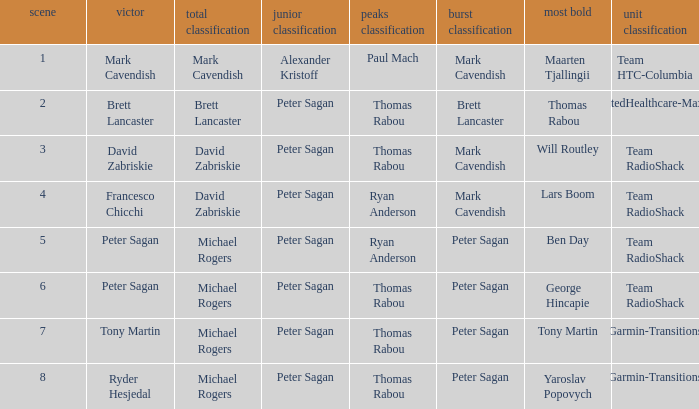When Mark Cavendish wins sprint classification and Maarten Tjallingii wins most courageous, who wins youth classification? Alexander Kristoff. 